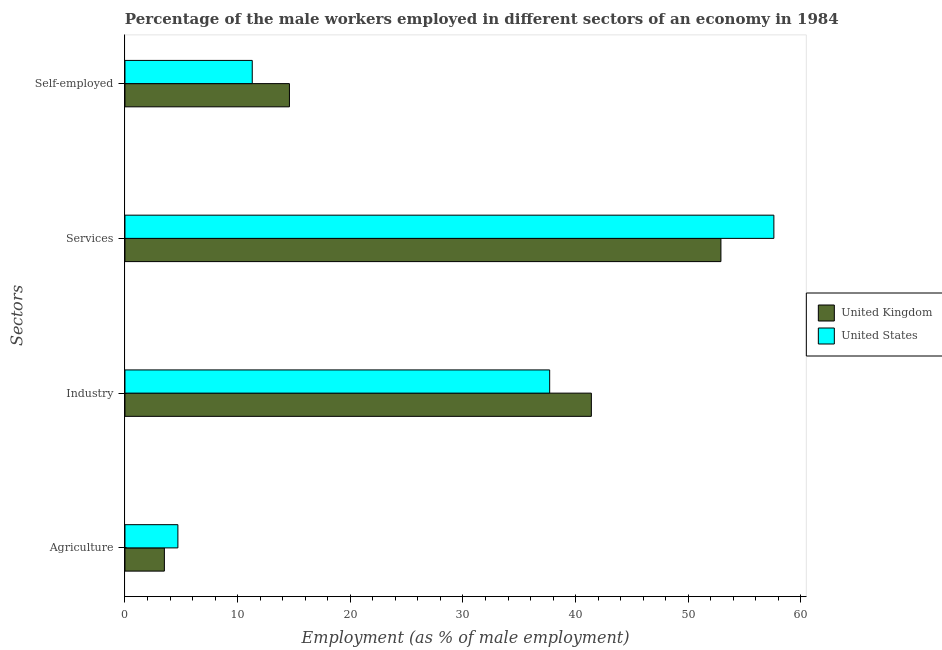How many different coloured bars are there?
Your response must be concise. 2. How many groups of bars are there?
Keep it short and to the point. 4. Are the number of bars per tick equal to the number of legend labels?
Provide a short and direct response. Yes. What is the label of the 1st group of bars from the top?
Give a very brief answer. Self-employed. What is the percentage of self employed male workers in United States?
Offer a terse response. 11.3. Across all countries, what is the maximum percentage of male workers in industry?
Offer a terse response. 41.4. Across all countries, what is the minimum percentage of male workers in agriculture?
Provide a short and direct response. 3.5. In which country was the percentage of male workers in agriculture maximum?
Ensure brevity in your answer.  United States. What is the total percentage of self employed male workers in the graph?
Make the answer very short. 25.9. What is the difference between the percentage of male workers in services in United States and that in United Kingdom?
Keep it short and to the point. 4.7. What is the difference between the percentage of male workers in services in United States and the percentage of male workers in agriculture in United Kingdom?
Provide a succinct answer. 54.1. What is the average percentage of male workers in industry per country?
Your response must be concise. 39.55. What is the difference between the percentage of male workers in industry and percentage of self employed male workers in United Kingdom?
Offer a terse response. 26.8. What is the ratio of the percentage of male workers in industry in United States to that in United Kingdom?
Ensure brevity in your answer.  0.91. What is the difference between the highest and the second highest percentage of male workers in services?
Offer a terse response. 4.7. What is the difference between the highest and the lowest percentage of male workers in services?
Provide a short and direct response. 4.7. In how many countries, is the percentage of male workers in industry greater than the average percentage of male workers in industry taken over all countries?
Your response must be concise. 1. What does the 1st bar from the bottom in Agriculture represents?
Ensure brevity in your answer.  United Kingdom. How many bars are there?
Ensure brevity in your answer.  8. How many countries are there in the graph?
Keep it short and to the point. 2. Does the graph contain any zero values?
Offer a very short reply. No. Does the graph contain grids?
Your answer should be compact. No. How are the legend labels stacked?
Make the answer very short. Vertical. What is the title of the graph?
Offer a terse response. Percentage of the male workers employed in different sectors of an economy in 1984. Does "Poland" appear as one of the legend labels in the graph?
Offer a very short reply. No. What is the label or title of the X-axis?
Your response must be concise. Employment (as % of male employment). What is the label or title of the Y-axis?
Your answer should be compact. Sectors. What is the Employment (as % of male employment) of United States in Agriculture?
Provide a succinct answer. 4.7. What is the Employment (as % of male employment) of United Kingdom in Industry?
Make the answer very short. 41.4. What is the Employment (as % of male employment) in United States in Industry?
Keep it short and to the point. 37.7. What is the Employment (as % of male employment) of United Kingdom in Services?
Provide a succinct answer. 52.9. What is the Employment (as % of male employment) of United States in Services?
Offer a terse response. 57.6. What is the Employment (as % of male employment) in United Kingdom in Self-employed?
Provide a succinct answer. 14.6. What is the Employment (as % of male employment) of United States in Self-employed?
Ensure brevity in your answer.  11.3. Across all Sectors, what is the maximum Employment (as % of male employment) of United Kingdom?
Ensure brevity in your answer.  52.9. Across all Sectors, what is the maximum Employment (as % of male employment) of United States?
Provide a succinct answer. 57.6. Across all Sectors, what is the minimum Employment (as % of male employment) in United States?
Your answer should be very brief. 4.7. What is the total Employment (as % of male employment) in United Kingdom in the graph?
Ensure brevity in your answer.  112.4. What is the total Employment (as % of male employment) of United States in the graph?
Offer a very short reply. 111.3. What is the difference between the Employment (as % of male employment) of United Kingdom in Agriculture and that in Industry?
Offer a very short reply. -37.9. What is the difference between the Employment (as % of male employment) of United States in Agriculture and that in Industry?
Make the answer very short. -33. What is the difference between the Employment (as % of male employment) of United Kingdom in Agriculture and that in Services?
Your answer should be compact. -49.4. What is the difference between the Employment (as % of male employment) in United States in Agriculture and that in Services?
Offer a terse response. -52.9. What is the difference between the Employment (as % of male employment) of United Kingdom in Agriculture and that in Self-employed?
Your answer should be very brief. -11.1. What is the difference between the Employment (as % of male employment) in United States in Agriculture and that in Self-employed?
Offer a very short reply. -6.6. What is the difference between the Employment (as % of male employment) in United Kingdom in Industry and that in Services?
Provide a short and direct response. -11.5. What is the difference between the Employment (as % of male employment) in United States in Industry and that in Services?
Keep it short and to the point. -19.9. What is the difference between the Employment (as % of male employment) of United Kingdom in Industry and that in Self-employed?
Provide a succinct answer. 26.8. What is the difference between the Employment (as % of male employment) of United States in Industry and that in Self-employed?
Your answer should be very brief. 26.4. What is the difference between the Employment (as % of male employment) of United Kingdom in Services and that in Self-employed?
Ensure brevity in your answer.  38.3. What is the difference between the Employment (as % of male employment) of United States in Services and that in Self-employed?
Keep it short and to the point. 46.3. What is the difference between the Employment (as % of male employment) of United Kingdom in Agriculture and the Employment (as % of male employment) of United States in Industry?
Provide a short and direct response. -34.2. What is the difference between the Employment (as % of male employment) of United Kingdom in Agriculture and the Employment (as % of male employment) of United States in Services?
Your response must be concise. -54.1. What is the difference between the Employment (as % of male employment) of United Kingdom in Agriculture and the Employment (as % of male employment) of United States in Self-employed?
Ensure brevity in your answer.  -7.8. What is the difference between the Employment (as % of male employment) in United Kingdom in Industry and the Employment (as % of male employment) in United States in Services?
Your answer should be compact. -16.2. What is the difference between the Employment (as % of male employment) of United Kingdom in Industry and the Employment (as % of male employment) of United States in Self-employed?
Provide a succinct answer. 30.1. What is the difference between the Employment (as % of male employment) of United Kingdom in Services and the Employment (as % of male employment) of United States in Self-employed?
Your answer should be very brief. 41.6. What is the average Employment (as % of male employment) of United Kingdom per Sectors?
Your answer should be very brief. 28.1. What is the average Employment (as % of male employment) in United States per Sectors?
Your answer should be very brief. 27.82. What is the difference between the Employment (as % of male employment) of United Kingdom and Employment (as % of male employment) of United States in Services?
Offer a terse response. -4.7. What is the ratio of the Employment (as % of male employment) of United Kingdom in Agriculture to that in Industry?
Offer a very short reply. 0.08. What is the ratio of the Employment (as % of male employment) in United States in Agriculture to that in Industry?
Provide a succinct answer. 0.12. What is the ratio of the Employment (as % of male employment) of United Kingdom in Agriculture to that in Services?
Provide a succinct answer. 0.07. What is the ratio of the Employment (as % of male employment) in United States in Agriculture to that in Services?
Your answer should be compact. 0.08. What is the ratio of the Employment (as % of male employment) of United Kingdom in Agriculture to that in Self-employed?
Offer a very short reply. 0.24. What is the ratio of the Employment (as % of male employment) in United States in Agriculture to that in Self-employed?
Offer a very short reply. 0.42. What is the ratio of the Employment (as % of male employment) in United Kingdom in Industry to that in Services?
Offer a terse response. 0.78. What is the ratio of the Employment (as % of male employment) in United States in Industry to that in Services?
Give a very brief answer. 0.65. What is the ratio of the Employment (as % of male employment) in United Kingdom in Industry to that in Self-employed?
Ensure brevity in your answer.  2.84. What is the ratio of the Employment (as % of male employment) in United States in Industry to that in Self-employed?
Offer a terse response. 3.34. What is the ratio of the Employment (as % of male employment) in United Kingdom in Services to that in Self-employed?
Ensure brevity in your answer.  3.62. What is the ratio of the Employment (as % of male employment) of United States in Services to that in Self-employed?
Make the answer very short. 5.1. What is the difference between the highest and the second highest Employment (as % of male employment) of United Kingdom?
Keep it short and to the point. 11.5. What is the difference between the highest and the second highest Employment (as % of male employment) of United States?
Provide a short and direct response. 19.9. What is the difference between the highest and the lowest Employment (as % of male employment) in United Kingdom?
Offer a very short reply. 49.4. What is the difference between the highest and the lowest Employment (as % of male employment) in United States?
Ensure brevity in your answer.  52.9. 